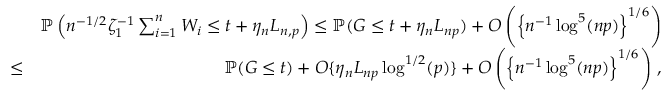<formula> <loc_0><loc_0><loc_500><loc_500>\begin{array} { r l r } & { { \mathbb { P } } \left ( n ^ { - 1 / 2 } \zeta _ { 1 } ^ { - 1 } \sum _ { i = 1 } ^ { n } W _ { i } \leq t + \eta _ { n } L _ { n , p } \right ) \leq { \mathbb { P } } ( G \leq t + \eta _ { n } L _ { n p } ) + O \left ( \left \{ n ^ { - 1 } \log ^ { 5 } ( n p ) \right \} ^ { 1 / 6 } \right ) } \\ & { \leq } & { { \mathbb { P } } ( G \leq t ) + O \{ \eta _ { n } L _ { n p } \log ^ { 1 / 2 } ( p ) \} + O \left ( \left \{ n ^ { - 1 } \log ^ { 5 } ( n p ) \right \} ^ { 1 / 6 } \right ) \, , } \end{array}</formula> 